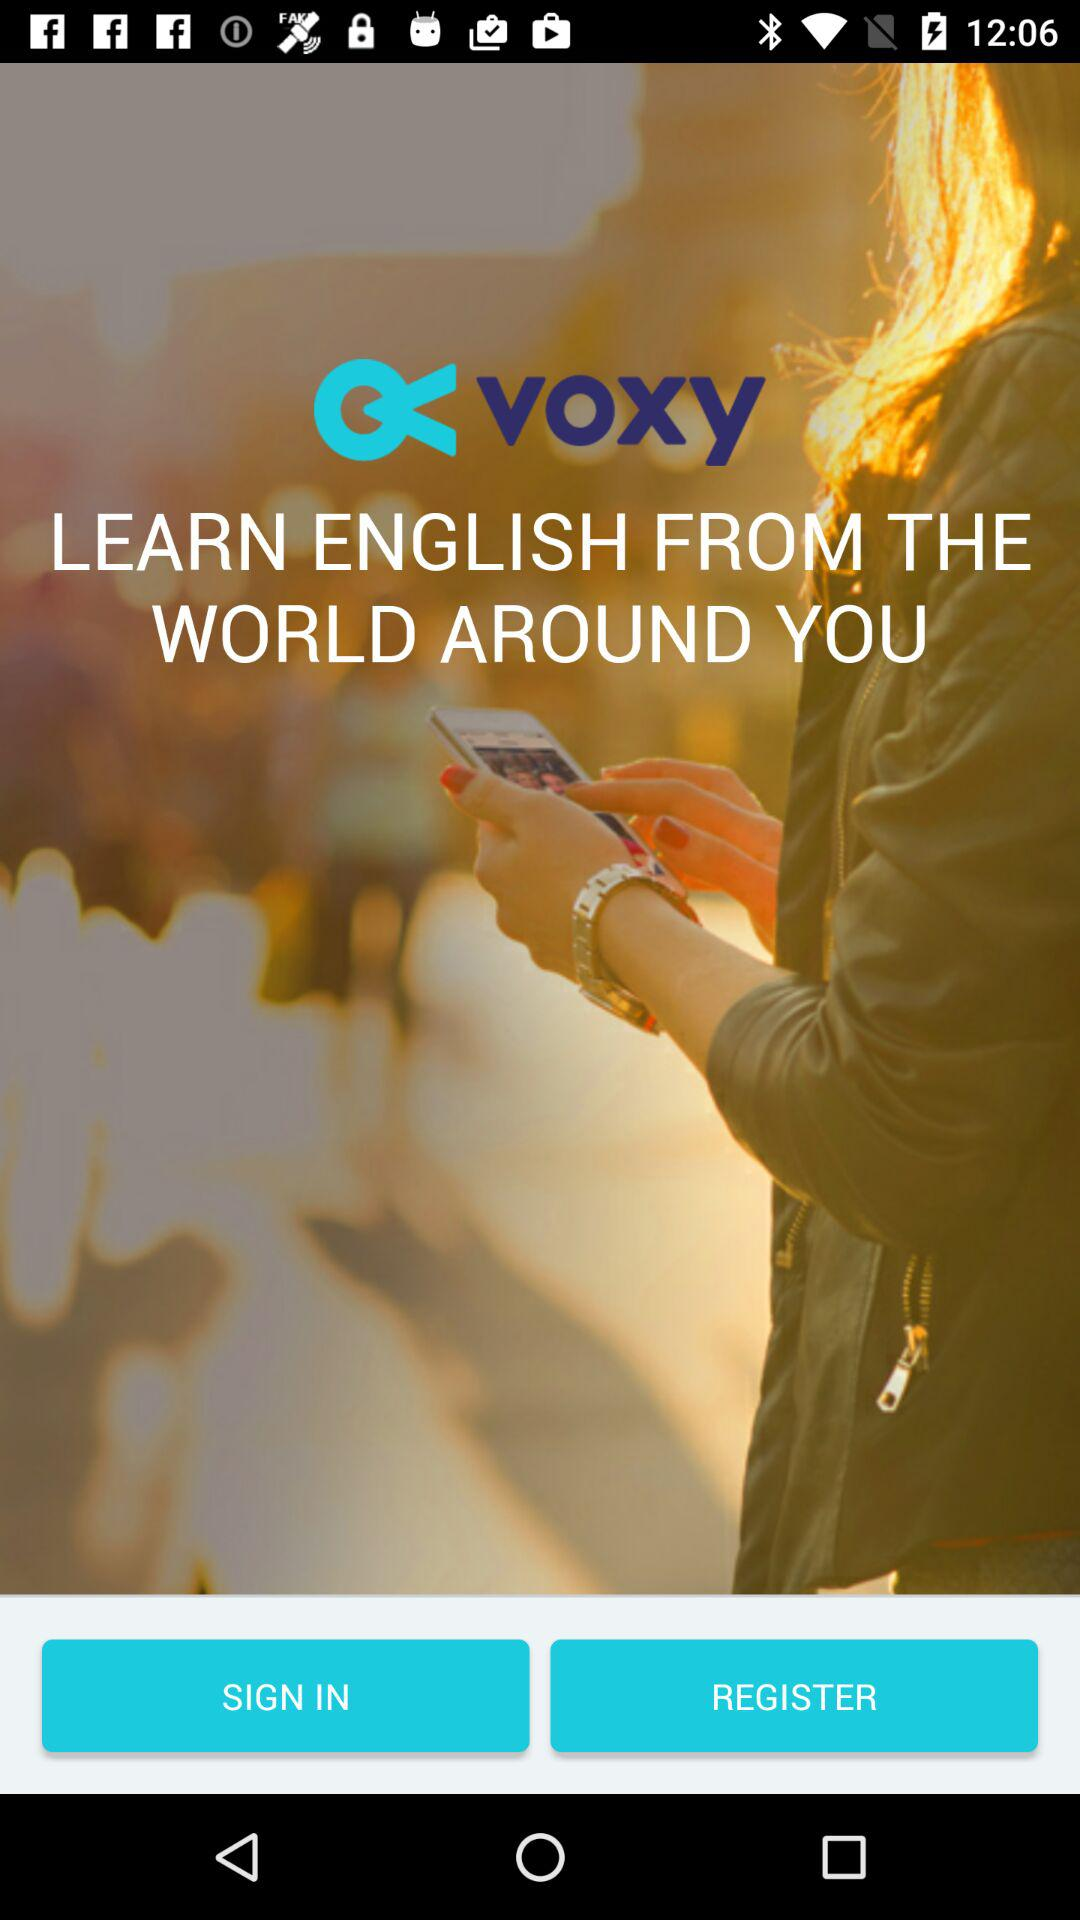What is the name of the application? The application name is "voxy". 